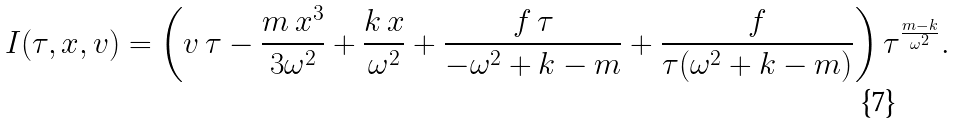<formula> <loc_0><loc_0><loc_500><loc_500>I ( \tau , x , v ) = \left ( v \, \tau - \frac { m \, x ^ { 3 } } { 3 \omega ^ { 2 } } + \frac { k \, x } { \omega ^ { 2 } } + \frac { f \, \tau } { - \omega ^ { 2 } + k - m } + \frac { f } { \tau ( \omega ^ { 2 } + k - m ) } \right ) \tau ^ { \frac { m - k } { \omega ^ { 2 } } } .</formula> 